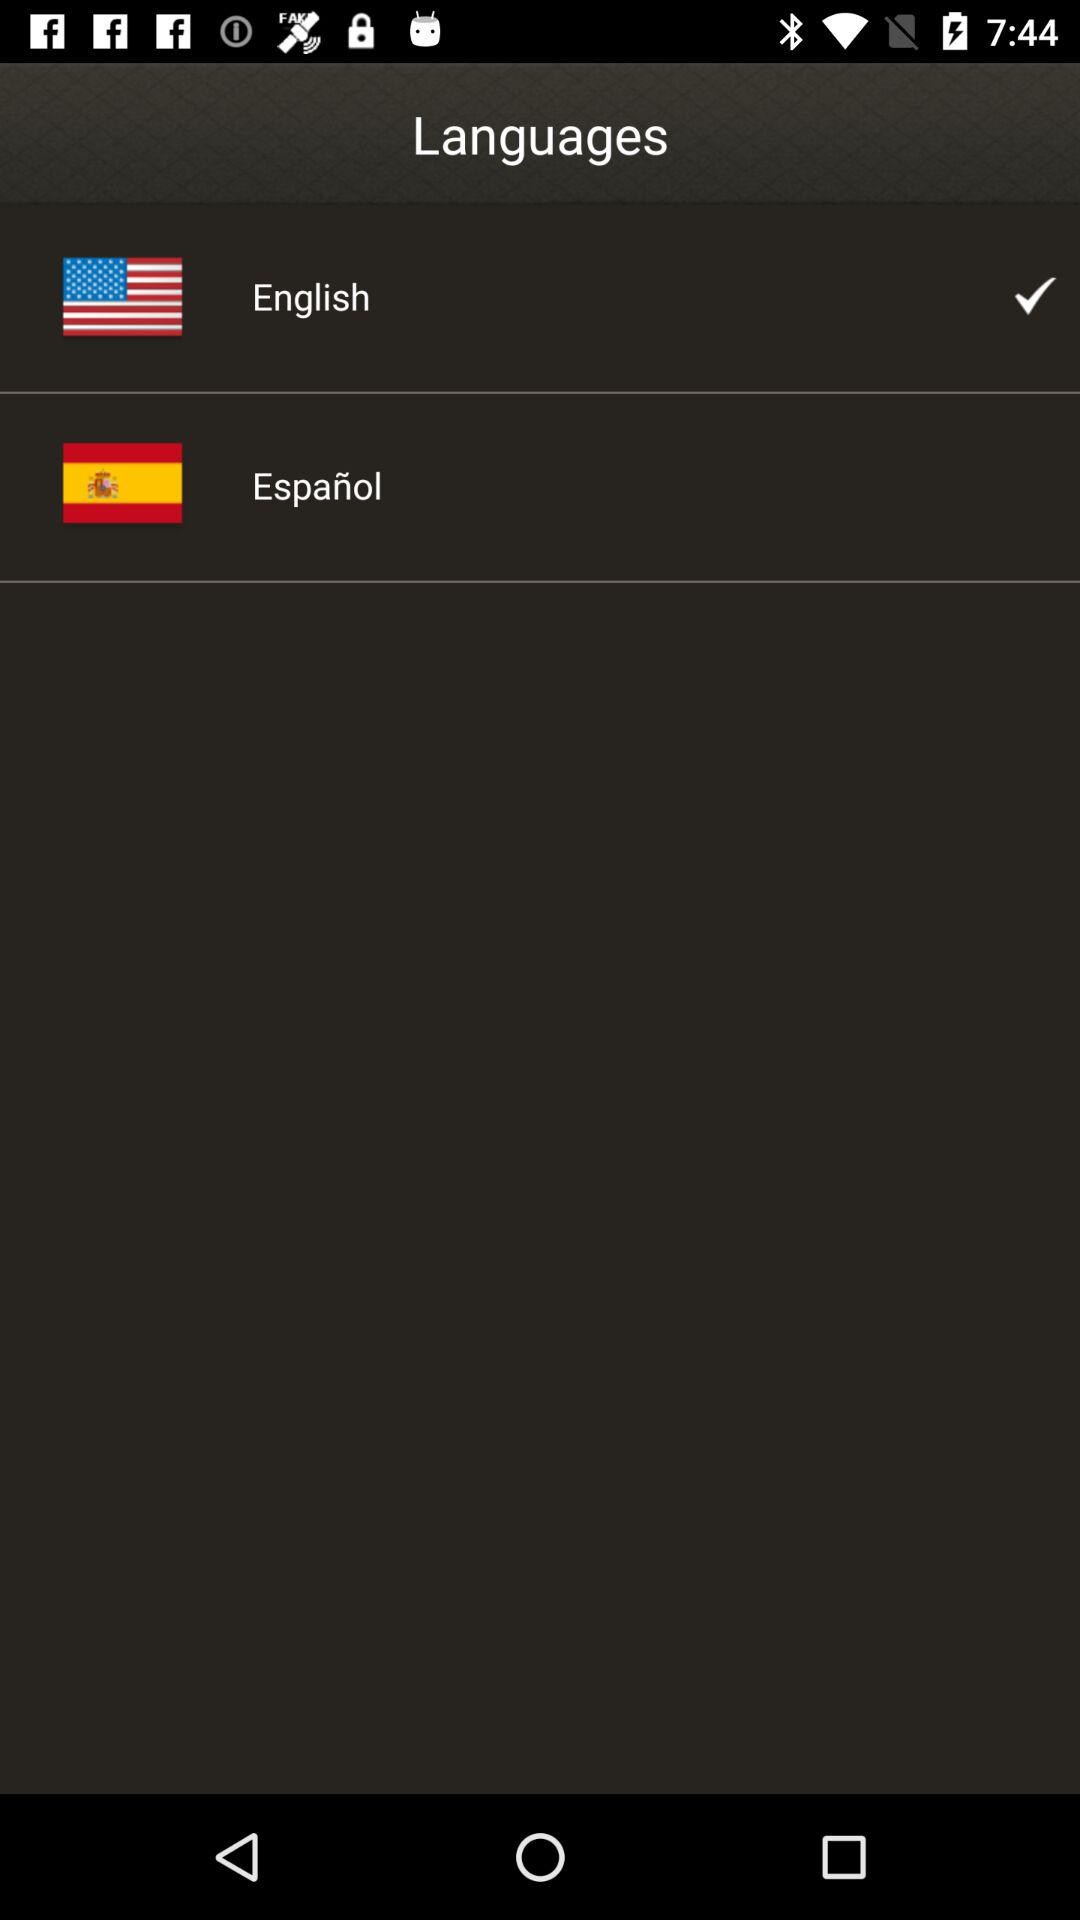What is the selected language? The selected language is "English". 